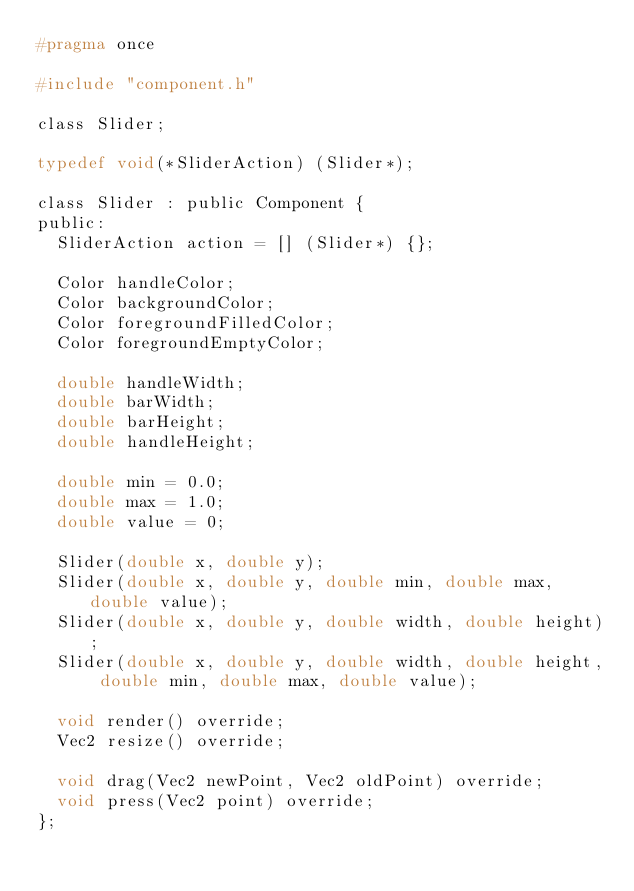Convert code to text. <code><loc_0><loc_0><loc_500><loc_500><_C_>#pragma once

#include "component.h"

class Slider;

typedef void(*SliderAction) (Slider*);

class Slider : public Component {
public:
	SliderAction action = [] (Slider*) {};

	Color handleColor;
	Color backgroundColor;
	Color foregroundFilledColor;
	Color foregroundEmptyColor;

	double handleWidth;
	double barWidth;
	double barHeight;
	double handleHeight;

	double min = 0.0;
	double max = 1.0;
	double value = 0;

	Slider(double x, double y);
	Slider(double x, double y, double min, double max, double value);
	Slider(double x, double y, double width, double height);
	Slider(double x, double y, double width, double height, double min, double max, double value);

	void render() override;
	Vec2 resize() override;

	void drag(Vec2 newPoint, Vec2 oldPoint) override;
	void press(Vec2 point) override;
};</code> 